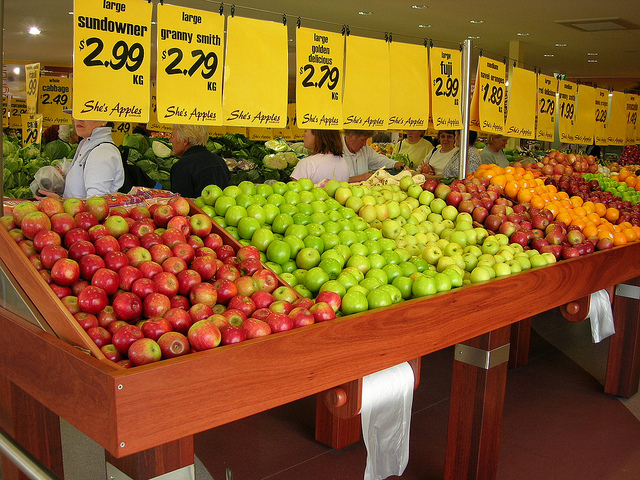Please transcribe the text information in this image. granny smith large delicious 99 249 1.49 079 1.49 223 1.99 2.79 1.89 2.99 2,79 APPLES She's Apples She's KG 2.79 large Apples Shas KG 2.99 sundowner large 